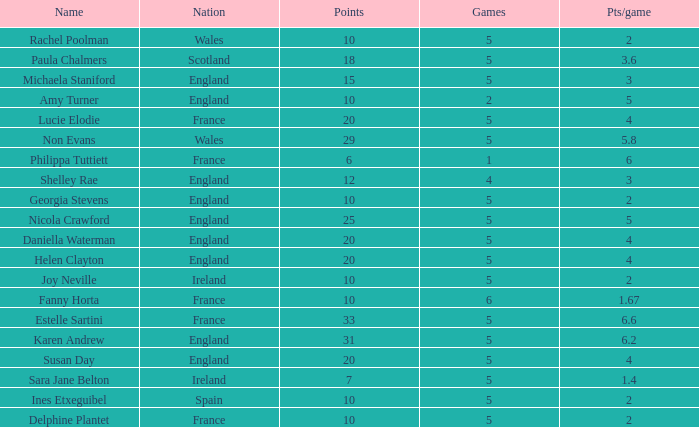Can you tell me the lowest Pts/game that has the Name of philippa tuttiett, and the Points larger then 6? None. 